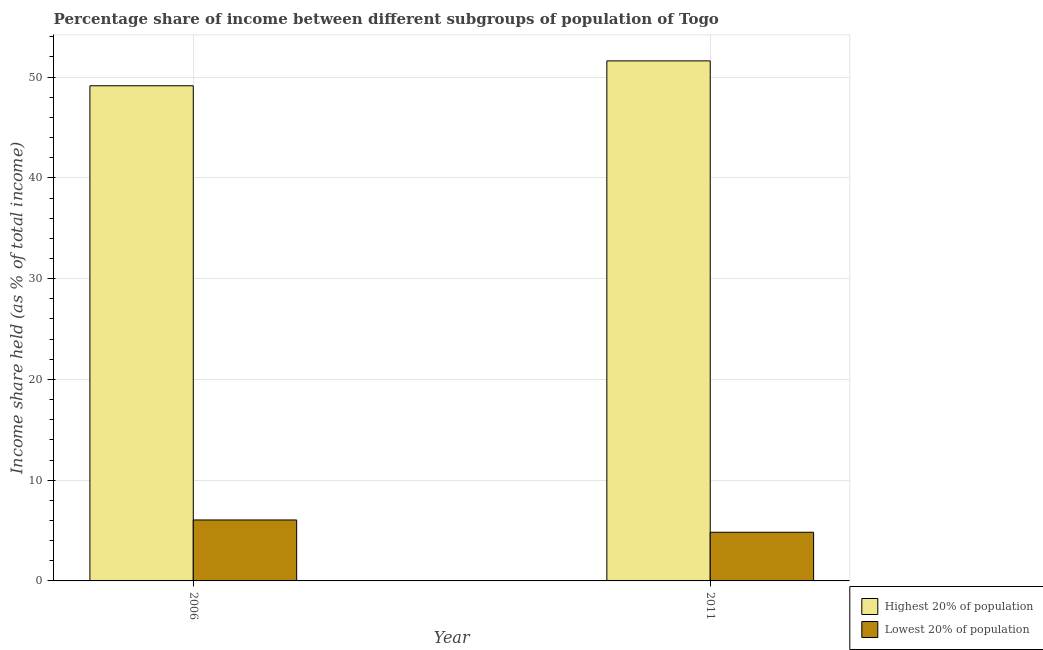Are the number of bars per tick equal to the number of legend labels?
Your response must be concise. Yes. How many bars are there on the 1st tick from the right?
Your response must be concise. 2. What is the label of the 2nd group of bars from the left?
Your answer should be compact. 2011. What is the income share held by highest 20% of the population in 2006?
Keep it short and to the point. 49.14. Across all years, what is the maximum income share held by lowest 20% of the population?
Keep it short and to the point. 6.05. Across all years, what is the minimum income share held by lowest 20% of the population?
Provide a succinct answer. 4.83. In which year was the income share held by lowest 20% of the population minimum?
Keep it short and to the point. 2011. What is the total income share held by highest 20% of the population in the graph?
Keep it short and to the point. 100.75. What is the difference between the income share held by highest 20% of the population in 2006 and that in 2011?
Your response must be concise. -2.47. What is the difference between the income share held by highest 20% of the population in 2011 and the income share held by lowest 20% of the population in 2006?
Give a very brief answer. 2.47. What is the average income share held by highest 20% of the population per year?
Ensure brevity in your answer.  50.38. In how many years, is the income share held by lowest 20% of the population greater than 2 %?
Provide a succinct answer. 2. What is the ratio of the income share held by lowest 20% of the population in 2006 to that in 2011?
Offer a very short reply. 1.25. What does the 2nd bar from the left in 2006 represents?
Offer a very short reply. Lowest 20% of population. What does the 2nd bar from the right in 2006 represents?
Provide a short and direct response. Highest 20% of population. Are the values on the major ticks of Y-axis written in scientific E-notation?
Offer a terse response. No. Does the graph contain any zero values?
Keep it short and to the point. No. How many legend labels are there?
Give a very brief answer. 2. What is the title of the graph?
Give a very brief answer. Percentage share of income between different subgroups of population of Togo. What is the label or title of the Y-axis?
Provide a short and direct response. Income share held (as % of total income). What is the Income share held (as % of total income) in Highest 20% of population in 2006?
Your response must be concise. 49.14. What is the Income share held (as % of total income) in Lowest 20% of population in 2006?
Make the answer very short. 6.05. What is the Income share held (as % of total income) in Highest 20% of population in 2011?
Ensure brevity in your answer.  51.61. What is the Income share held (as % of total income) in Lowest 20% of population in 2011?
Provide a succinct answer. 4.83. Across all years, what is the maximum Income share held (as % of total income) in Highest 20% of population?
Keep it short and to the point. 51.61. Across all years, what is the maximum Income share held (as % of total income) in Lowest 20% of population?
Your answer should be compact. 6.05. Across all years, what is the minimum Income share held (as % of total income) in Highest 20% of population?
Ensure brevity in your answer.  49.14. Across all years, what is the minimum Income share held (as % of total income) of Lowest 20% of population?
Provide a succinct answer. 4.83. What is the total Income share held (as % of total income) of Highest 20% of population in the graph?
Your response must be concise. 100.75. What is the total Income share held (as % of total income) of Lowest 20% of population in the graph?
Offer a very short reply. 10.88. What is the difference between the Income share held (as % of total income) in Highest 20% of population in 2006 and that in 2011?
Your answer should be very brief. -2.47. What is the difference between the Income share held (as % of total income) of Lowest 20% of population in 2006 and that in 2011?
Offer a very short reply. 1.22. What is the difference between the Income share held (as % of total income) in Highest 20% of population in 2006 and the Income share held (as % of total income) in Lowest 20% of population in 2011?
Provide a succinct answer. 44.31. What is the average Income share held (as % of total income) in Highest 20% of population per year?
Make the answer very short. 50.38. What is the average Income share held (as % of total income) of Lowest 20% of population per year?
Your answer should be very brief. 5.44. In the year 2006, what is the difference between the Income share held (as % of total income) in Highest 20% of population and Income share held (as % of total income) in Lowest 20% of population?
Offer a very short reply. 43.09. In the year 2011, what is the difference between the Income share held (as % of total income) of Highest 20% of population and Income share held (as % of total income) of Lowest 20% of population?
Your response must be concise. 46.78. What is the ratio of the Income share held (as % of total income) in Highest 20% of population in 2006 to that in 2011?
Offer a terse response. 0.95. What is the ratio of the Income share held (as % of total income) of Lowest 20% of population in 2006 to that in 2011?
Give a very brief answer. 1.25. What is the difference between the highest and the second highest Income share held (as % of total income) in Highest 20% of population?
Provide a short and direct response. 2.47. What is the difference between the highest and the second highest Income share held (as % of total income) of Lowest 20% of population?
Give a very brief answer. 1.22. What is the difference between the highest and the lowest Income share held (as % of total income) in Highest 20% of population?
Offer a very short reply. 2.47. What is the difference between the highest and the lowest Income share held (as % of total income) in Lowest 20% of population?
Give a very brief answer. 1.22. 